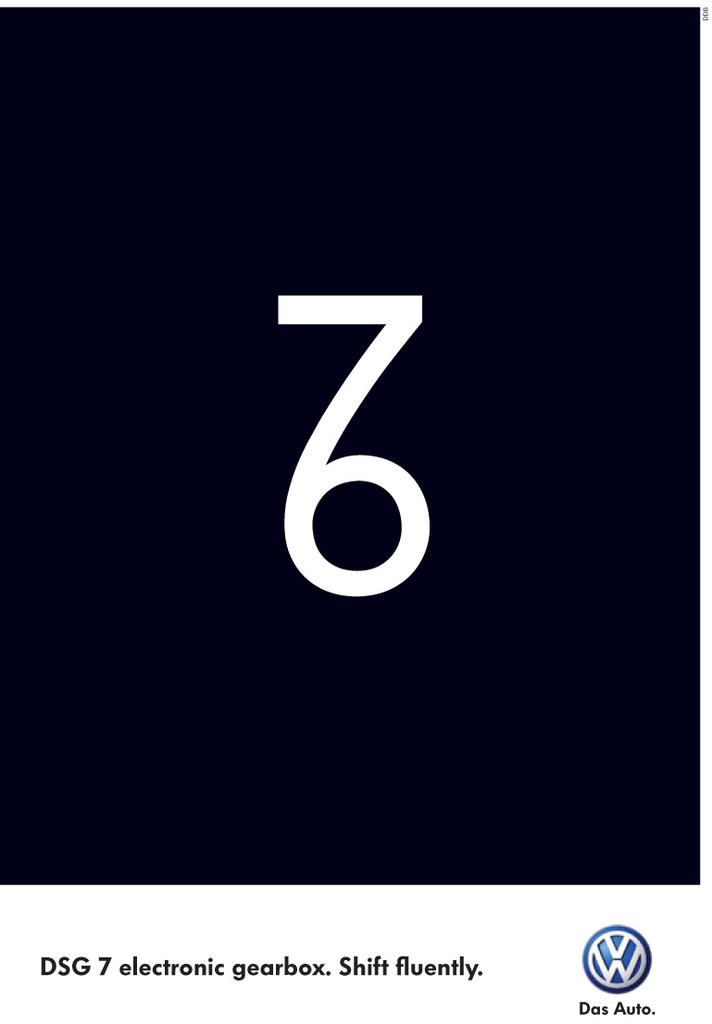<image>
Write a terse but informative summary of the picture. Volkswagen advertisement showing a 76 and electronic gearbox. 